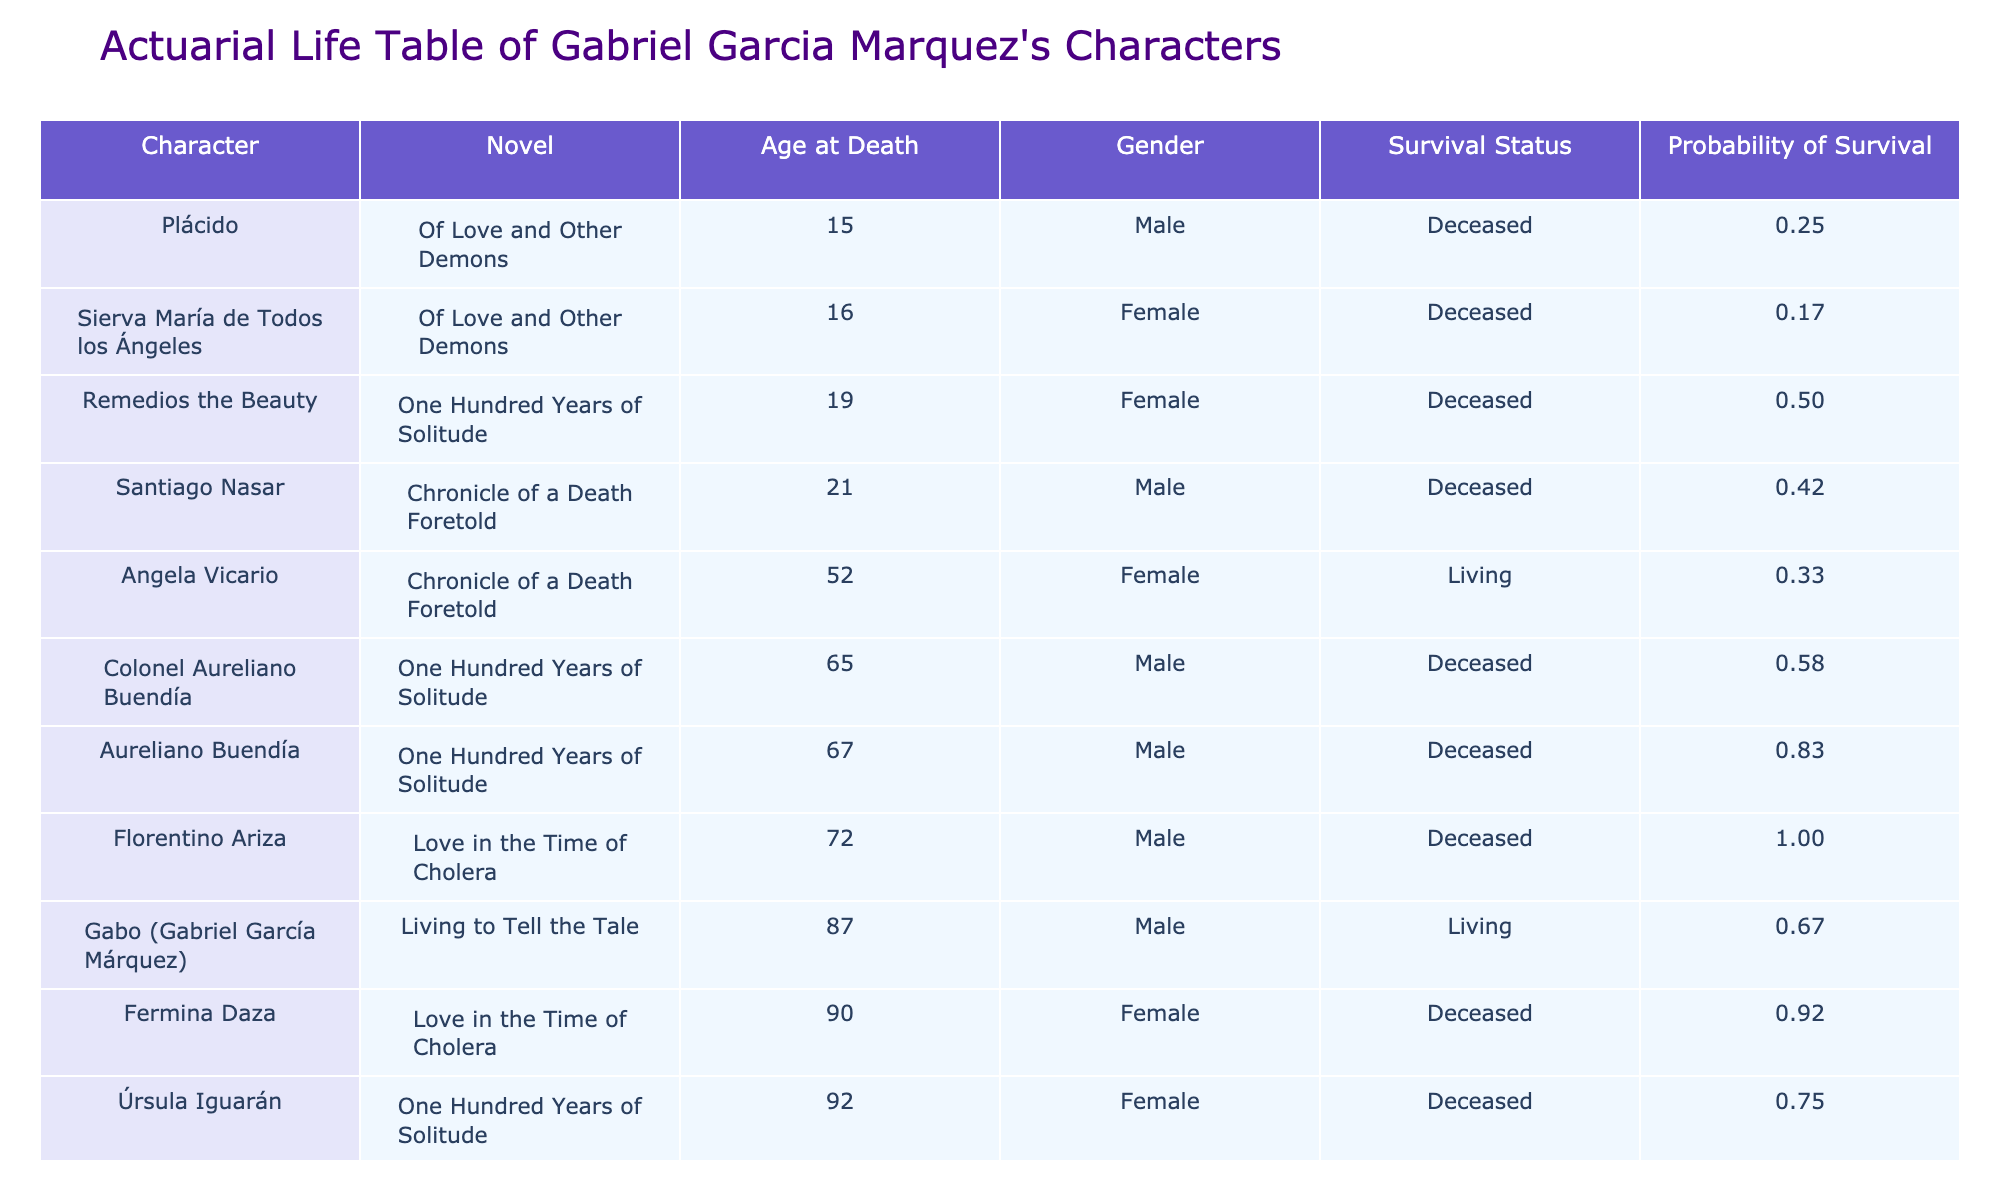What is the age at death of Florentino Ariza? In the table, I look under the "Character" column for Florentino Ariza and find that next to his name, the "Age at Death" listed is 72.
Answer: 72 How many characters in total are deceased? By scanning the "Survival Status" column, I count the number of occurrences of "Deceased." There are 8 characters listed as deceased out of the total of 11.
Answer: 8 What is the probability of survival for Angela Vicario? I find Angela Vicario in the table and look at her row, specifically in the "Probability of Survival" column. The value there is 0.27.
Answer: 0.27 Is Úrsula Iguarán alive? To answer this, I check the "Survival Status" column for Úrsula Iguarán. The entry is "Deceased," indicating she is not alive.
Answer: No Which character has the highest age at death? I review the "Age at Death" column and identify the maximum value. Melquíades has an age at death of 130, which is the highest when compared to all listed characters.
Answer: 130 What is the average age at death of female characters? I first identify the female characters: Fermina Daza (90), Úrsula Iguarán (92), Remedios the Beauty (19), and Angela Vicario (52). Their ages sum to (90 + 92 + 19 + 52 = 253), and since there are 4 females, the average is 253/4 = 63.25.
Answer: 63.25 Do more male characters live past 70 years of age than female characters? From the table, I check how many male characters (Florentino Ariza at 72 and Gabo at 87) and female characters (Fermina Daza at 90 and Úrsula Iguarán at 92) are above 70. There are 2 males and 2 females living past that age, therefore, the answer is no since they are equal.
Answer: No Which character had the lowest survival probability? I find the "Probability of Survival" values for all characters: Florentino Ariza (0.27), Fermina Daza (0.18), Aureliano Buendía (0.09), etc. The lowest probability is for Santiago Nasar, with a value of 0.09.
Answer: Santiago Nasar What proportion of the characters are living? There are 3 characters (Gabo and Angela Vicario) who are alive out of a total of 11 characters. The proportion is calculated as 3/11, which equals approximately 0.27.
Answer: 0.27 